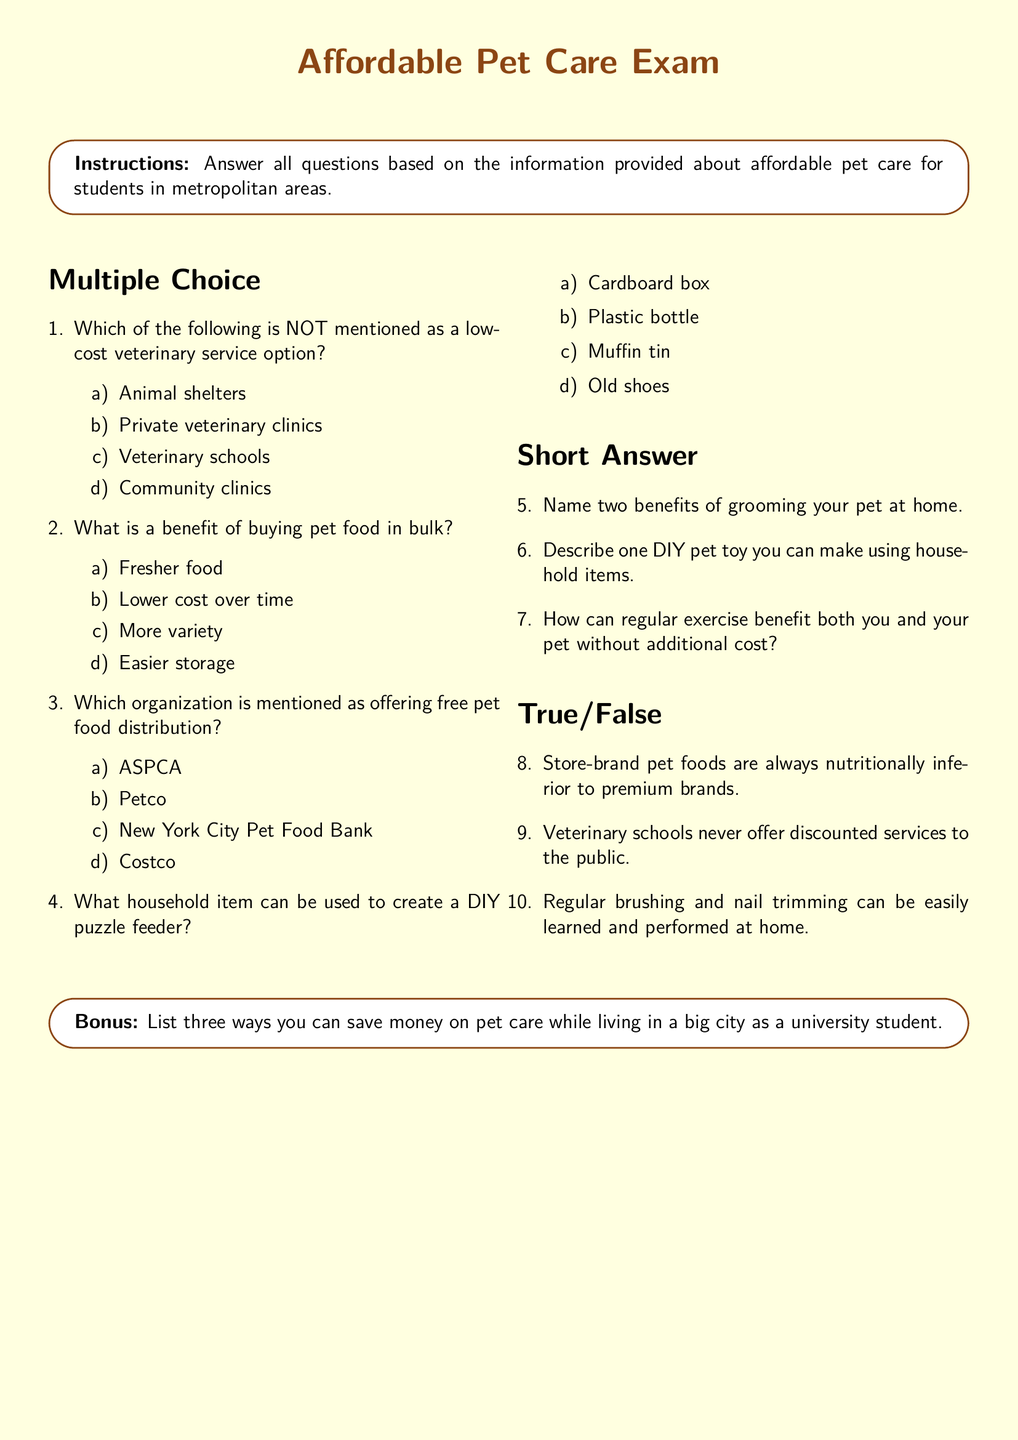What is the title of the document? The title of the document is given at the top center of the rendered page.
Answer: Affordable Pet Care Exam Which font is used for the document? The font specification is mentioned in the preamble of the document.
Answer: Comic Sans MS What is the color of the page background? The background color is defined in the document using specific RGB values.
Answer: Light yellow Name one type of low-cost veterinary service mentioned. The exam lists several options in the multiple-choice section for veterinary services.
Answer: Animal shelters What is one benefit of grooming your pet at home? This question is part of the short answer section requesting benefits listed in the document.
Answer: Cost saving What is one DIY pet toy you can make? This question prompts the examinee to refer to the short answer section for examples of DIY pet toys.
Answer: Cardboard box Are veterinary schools mentioned as offering discounted services? The true/false question refers to the information that identifies services provided by veterinary schools.
Answer: False What is the bonus question asking for? The bonus section of the document prompts for ways to save money on pet care as specified.
Answer: Three ways How many multiple-choice questions are included? The count of items in the multiple-choice section provides insight into the document's structure.
Answer: Four 